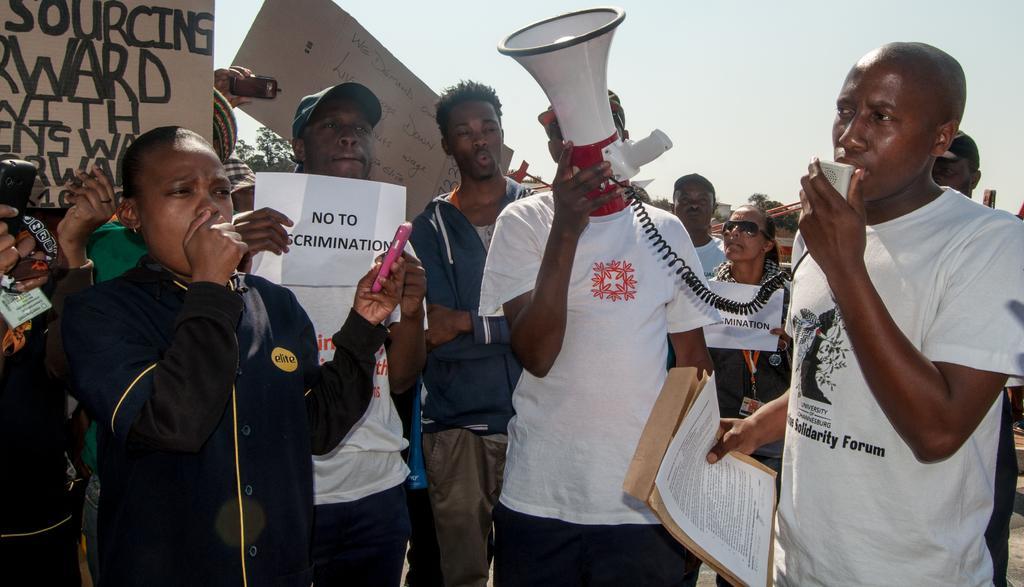Could you give a brief overview of what you see in this image? In this picture we can see a group of people. There are some people holding the boards and some people holding papers. A man is holding a megaphone. Behind the people, there are trees and the sky. 